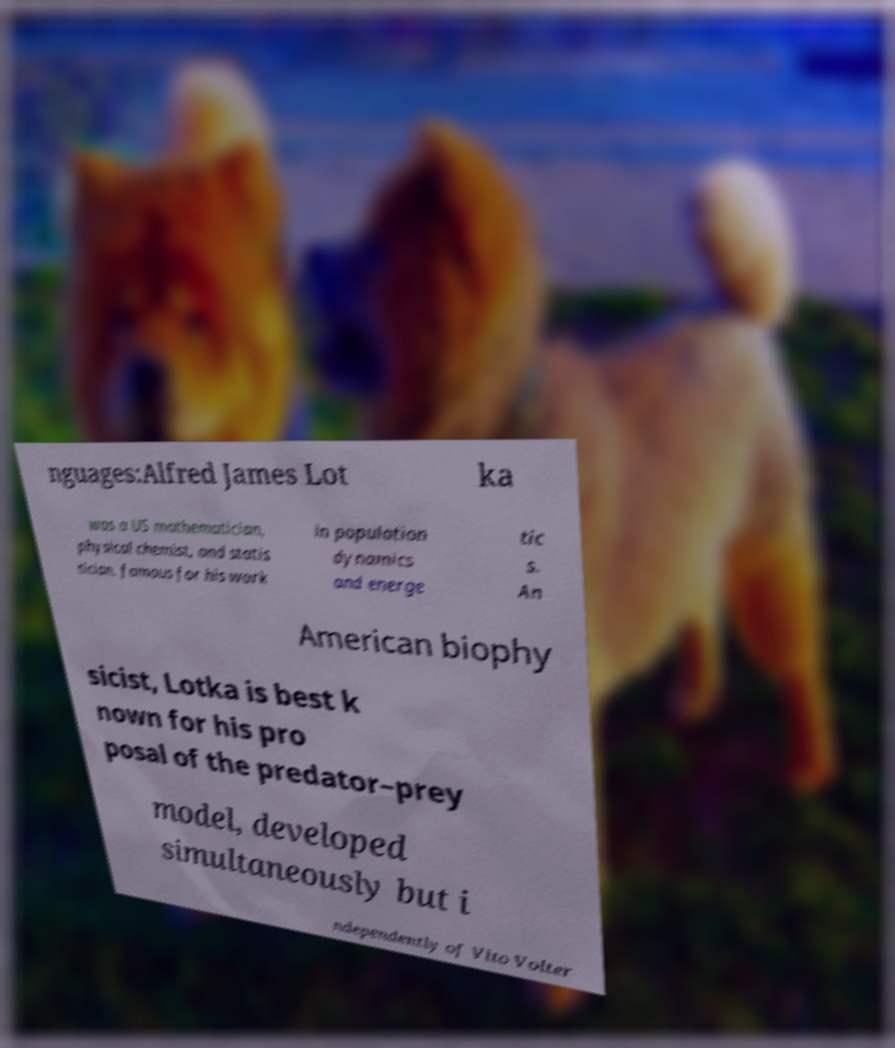Could you assist in decoding the text presented in this image and type it out clearly? nguages:Alfred James Lot ka was a US mathematician, physical chemist, and statis tician, famous for his work in population dynamics and energe tic s. An American biophy sicist, Lotka is best k nown for his pro posal of the predator–prey model, developed simultaneously but i ndependently of Vito Volter 